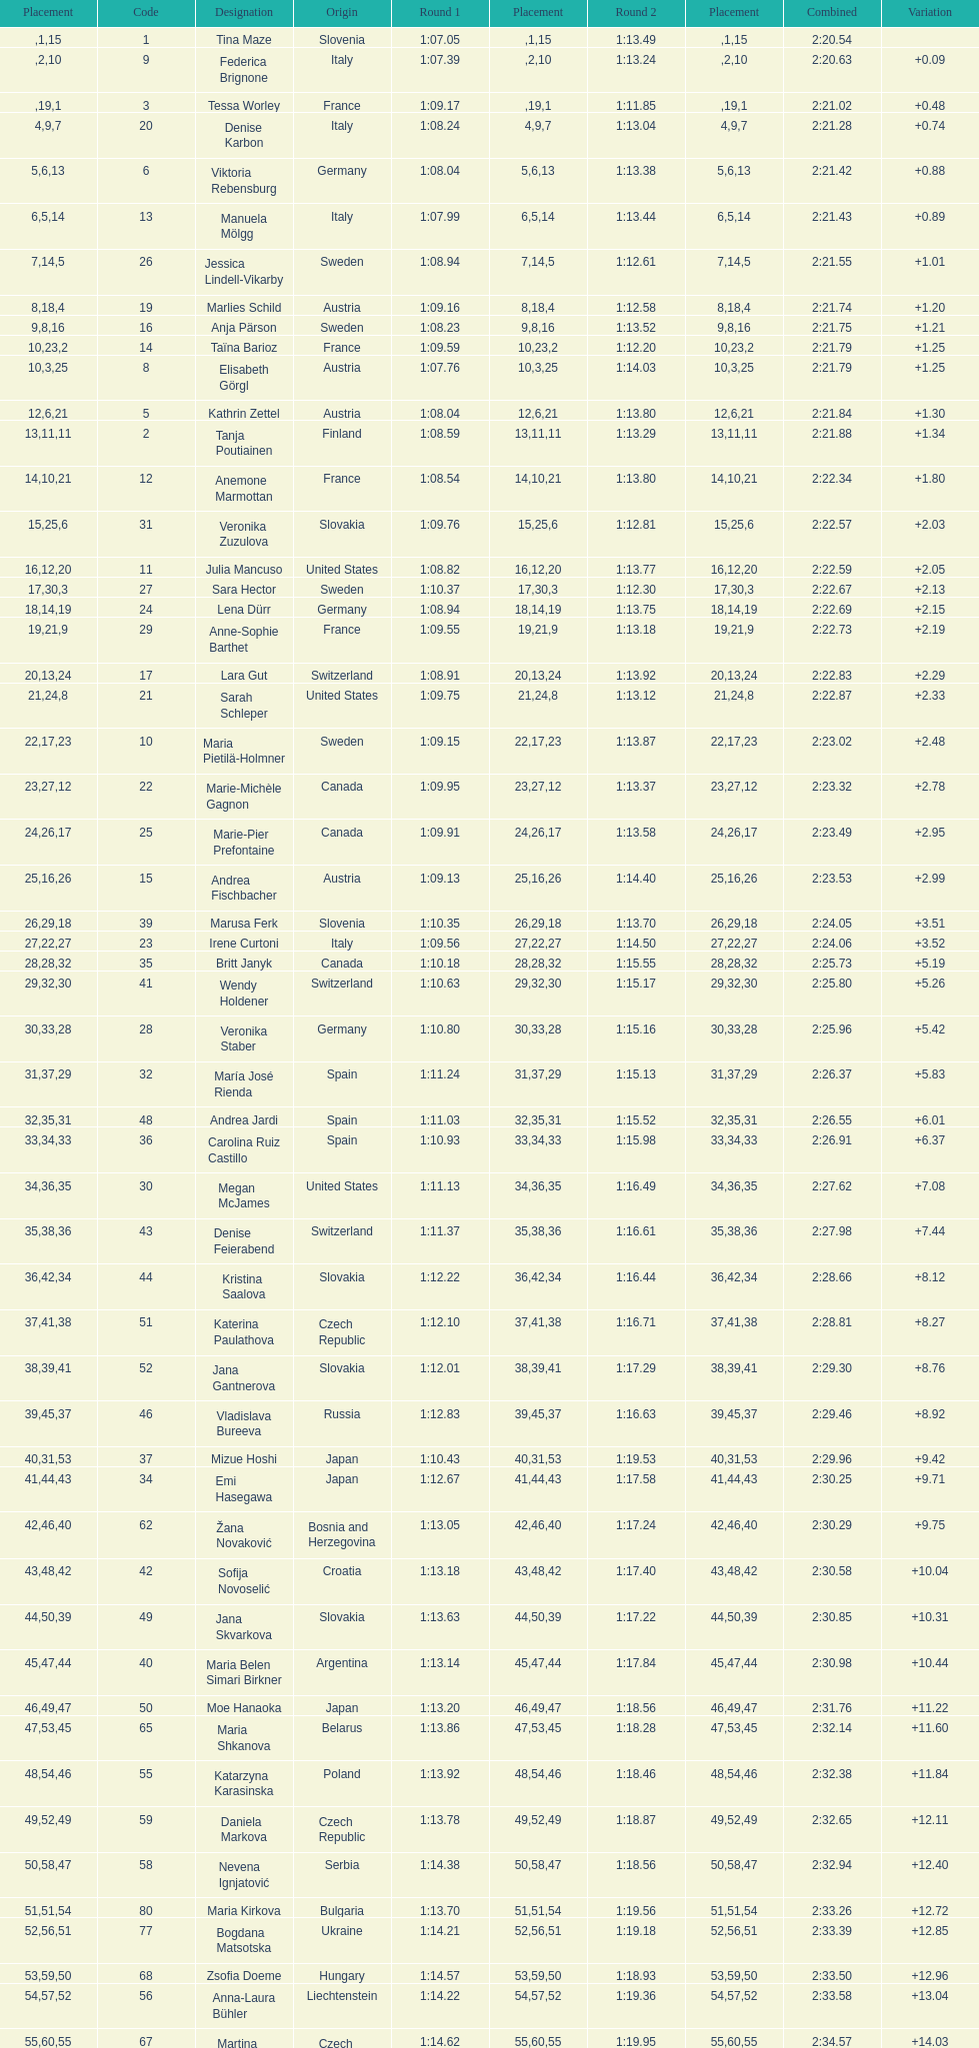How many italians finished in the top ten? 3. 